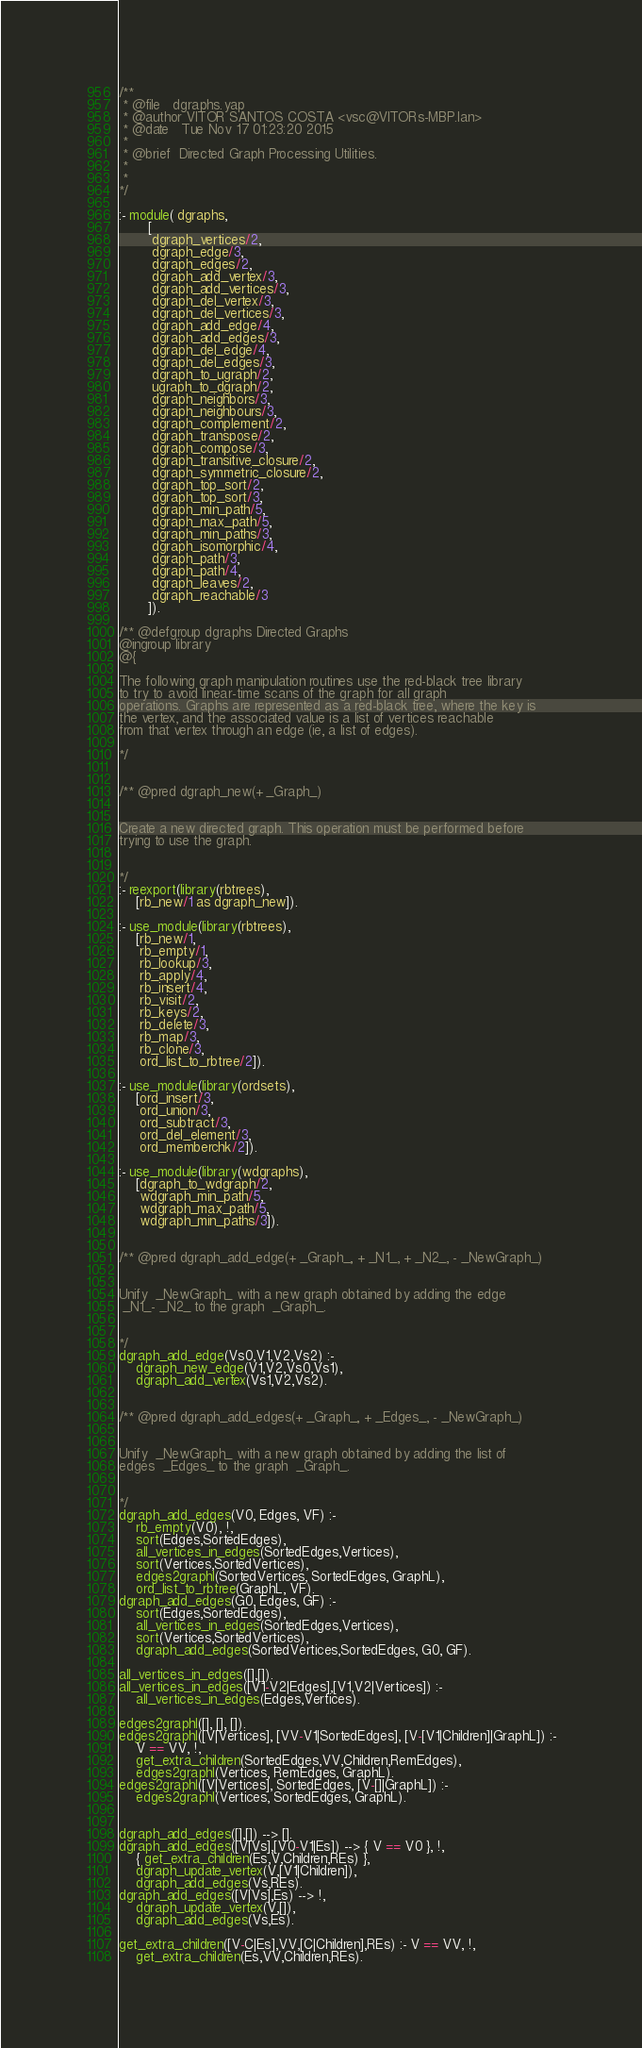<code> <loc_0><loc_0><loc_500><loc_500><_Prolog_>/**
 * @file   dgraphs.yap
 * @author VITOR SANTOS COSTA <vsc@VITORs-MBP.lan>
 * @date   Tue Nov 17 01:23:20 2015
 * 
 * @brief  Directed Graph Processing Utilities.
 * 
 * 
*/

:- module( dgraphs,
	   [
	    dgraph_vertices/2,
	    dgraph_edge/3,
	    dgraph_edges/2,
	    dgraph_add_vertex/3,
	    dgraph_add_vertices/3,
	    dgraph_del_vertex/3,
	    dgraph_del_vertices/3,
	    dgraph_add_edge/4,
	    dgraph_add_edges/3,
	    dgraph_del_edge/4,
	    dgraph_del_edges/3,
	    dgraph_to_ugraph/2,
	    ugraph_to_dgraph/2,
	    dgraph_neighbors/3,
	    dgraph_neighbours/3,
	    dgraph_complement/2,
	    dgraph_transpose/2,
	    dgraph_compose/3,
	    dgraph_transitive_closure/2,
	    dgraph_symmetric_closure/2,
	    dgraph_top_sort/2,
	    dgraph_top_sort/3,
	    dgraph_min_path/5,
	    dgraph_max_path/5,
	    dgraph_min_paths/3,
	    dgraph_isomorphic/4,
	    dgraph_path/3,
	    dgraph_path/4,
	    dgraph_leaves/2,
	    dgraph_reachable/3
       ]).

/** @defgroup dgraphs Directed Graphs
@ingroup library
@{

The following graph manipulation routines use the red-black tree library
to try to avoid linear-time scans of the graph for all graph
operations. Graphs are represented as a red-black tree, where the key is
the vertex, and the associated value is a list of vertices reachable
from that vertex through an edge (ie, a list of edges).

*/


/** @pred dgraph_new(+ _Graph_) 


Create a new directed graph. This operation must be performed before
trying to use the graph.

 
*/
:- reexport(library(rbtrees),
	[rb_new/1 as dgraph_new]).

:- use_module(library(rbtrees),
	[rb_new/1,
	 rb_empty/1,
	 rb_lookup/3,
	 rb_apply/4,
	 rb_insert/4,
	 rb_visit/2,
	 rb_keys/2,
	 rb_delete/3,
	 rb_map/3,
	 rb_clone/3,
	 ord_list_to_rbtree/2]).

:- use_module(library(ordsets),
	[ord_insert/3,
	 ord_union/3,
	 ord_subtract/3,
	 ord_del_element/3,
	 ord_memberchk/2]).

:- use_module(library(wdgraphs),
	[dgraph_to_wdgraph/2,
	 wdgraph_min_path/5,
	 wdgraph_max_path/5,
	 wdgraph_min_paths/3]).


/** @pred dgraph_add_edge(+ _Graph_, + _N1_, + _N2_, - _NewGraph_) 


Unify  _NewGraph_ with a new graph obtained by adding the edge
 _N1_- _N2_ to the graph  _Graph_.

 
*/
dgraph_add_edge(Vs0,V1,V2,Vs2) :-
	dgraph_new_edge(V1,V2,Vs0,Vs1),
	dgraph_add_vertex(Vs1,V2,Vs2).
	

/** @pred dgraph_add_edges(+ _Graph_, + _Edges_, - _NewGraph_) 


Unify  _NewGraph_ with a new graph obtained by adding the list of
edges  _Edges_ to the graph  _Graph_.

 
*/
dgraph_add_edges(V0, Edges, VF) :-
	rb_empty(V0), !,
	sort(Edges,SortedEdges),
	all_vertices_in_edges(SortedEdges,Vertices),
	sort(Vertices,SortedVertices),
	edges2graphl(SortedVertices, SortedEdges, GraphL),
	ord_list_to_rbtree(GraphL, VF).
dgraph_add_edges(G0, Edges, GF) :-
	sort(Edges,SortedEdges),
	all_vertices_in_edges(SortedEdges,Vertices),
	sort(Vertices,SortedVertices),
	dgraph_add_edges(SortedVertices,SortedEdges, G0, GF).

all_vertices_in_edges([],[]).
all_vertices_in_edges([V1-V2|Edges],[V1,V2|Vertices]) :-
	all_vertices_in_edges(Edges,Vertices).	 

edges2graphl([], [], []).
edges2graphl([V|Vertices], [VV-V1|SortedEdges], [V-[V1|Children]|GraphL]) :-
	V == VV, !,
	get_extra_children(SortedEdges,VV,Children,RemEdges),
	edges2graphl(Vertices, RemEdges, GraphL).
edges2graphl([V|Vertices], SortedEdges, [V-[]|GraphL]) :-
	edges2graphl(Vertices, SortedEdges, GraphL).


dgraph_add_edges([],[]) --> [].
dgraph_add_edges([V|Vs],[V0-V1|Es]) --> { V == V0 }, !,
	{ get_extra_children(Es,V,Children,REs) },
	dgraph_update_vertex(V,[V1|Children]),
	dgraph_add_edges(Vs,REs).
dgraph_add_edges([V|Vs],Es) --> !,
	dgraph_update_vertex(V,[]),
	dgraph_add_edges(Vs,Es).

get_extra_children([V-C|Es],VV,[C|Children],REs) :- V == VV, !,
	get_extra_children(Es,VV,Children,REs).</code> 